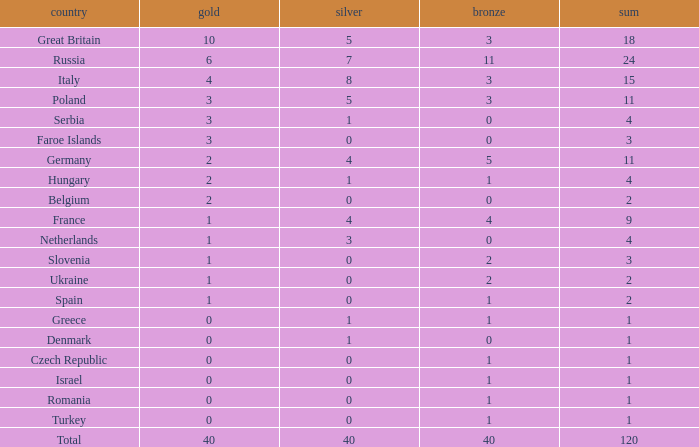What Nation has a Gold entry that is greater than 0, a Total that is greater than 2, a Silver entry that is larger than 1, and 0 Bronze? Netherlands. 